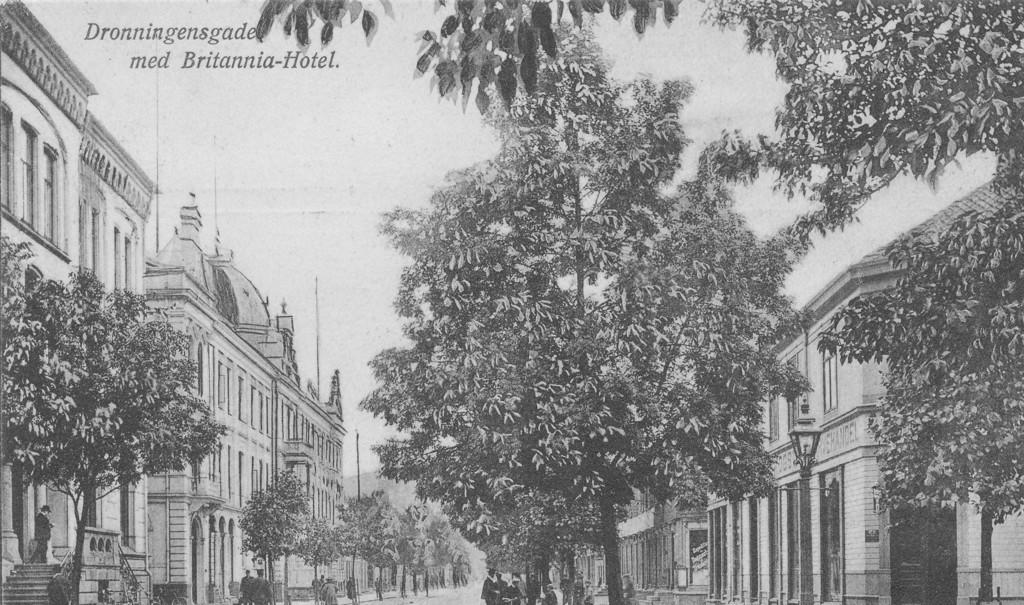What type of photo is in the image? The image contains a black and white photo. What can be seen in the photo? There are trees, buildings, and people on the road in the photo. How many girls are holding sticks in the photo? There are no girls or sticks present in the photo; it features trees, buildings, and people on the road. 